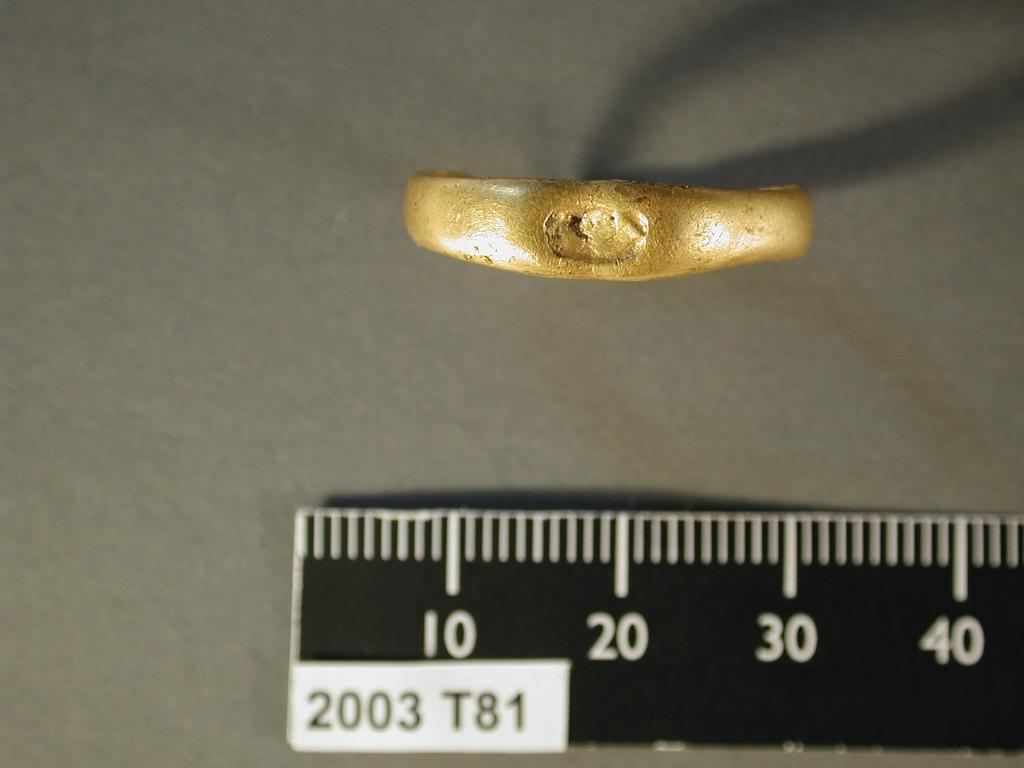<image>
Present a compact description of the photo's key features. A piece of or possibly ring of gold being measured on a ruler that says 2003 T81. 